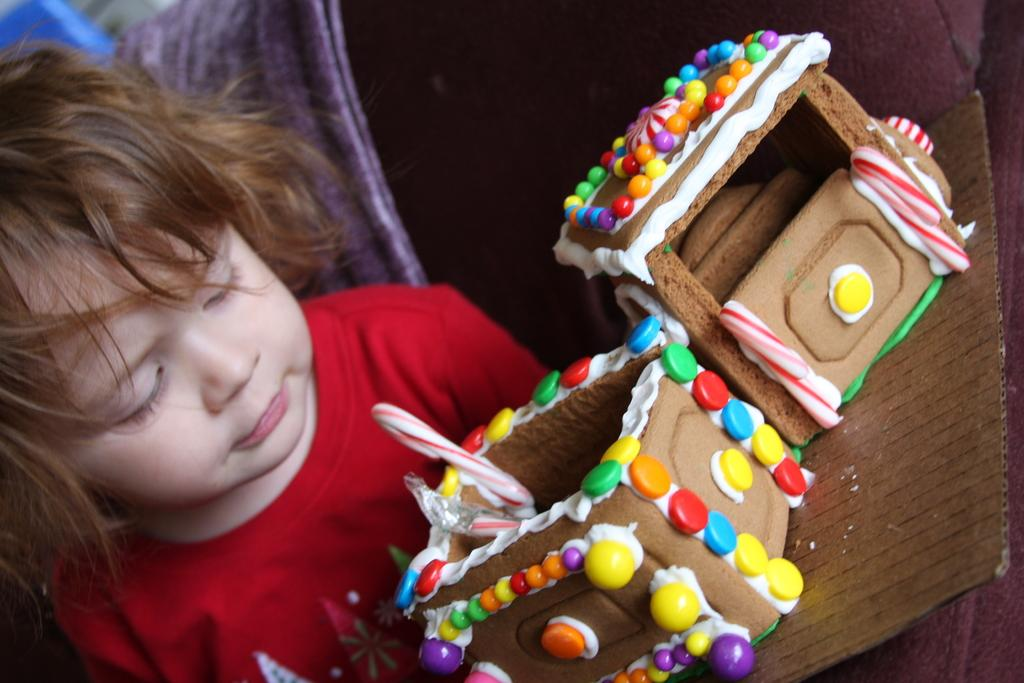What is the main subject of the image? The main subject of the image is a kid. What is the kid wearing? The kid is wearing a red dress. What can be seen in front of the kid? There are eatables placed in front of the kid. What type of egg is being used to create the channel in the image? There is no egg or channel present in the image. How does the kid express regret in the image? The image does not show the kid expressing regret, as it only features the kid wearing a red dress and eatables placed in front of them. 